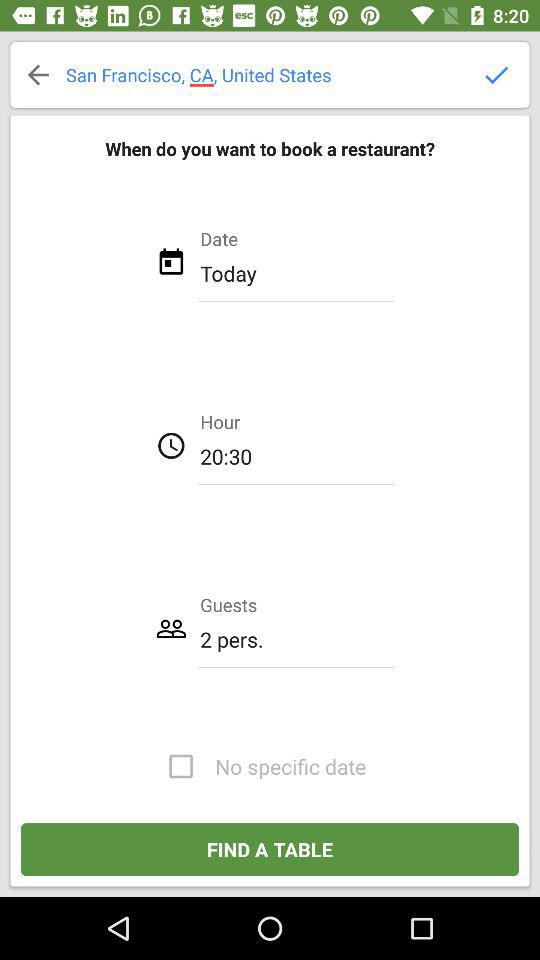For what time do I want to book the restaurant? You want to book the restaurant for 20:30. 